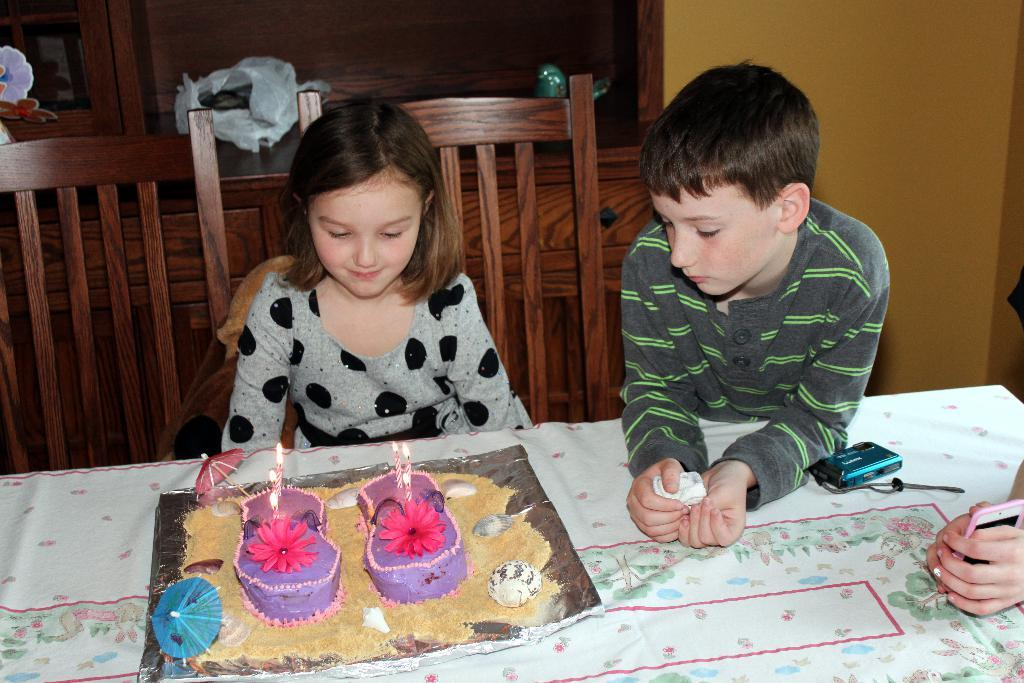What is the girl doing in the image? The girl is sitting on a chair in the image. What is the girl looking at while sitting on the chair? The girl is looking at a cake on a table. Is there anyone else in the image with the girl? Yes, there is a boy beside the girl. What is the boy doing in the image? The boy is also looking at the cake on the table. Can you see any wounds on the girl or boy in the image? There is no mention of any wounds on the girl or boy in the image. 